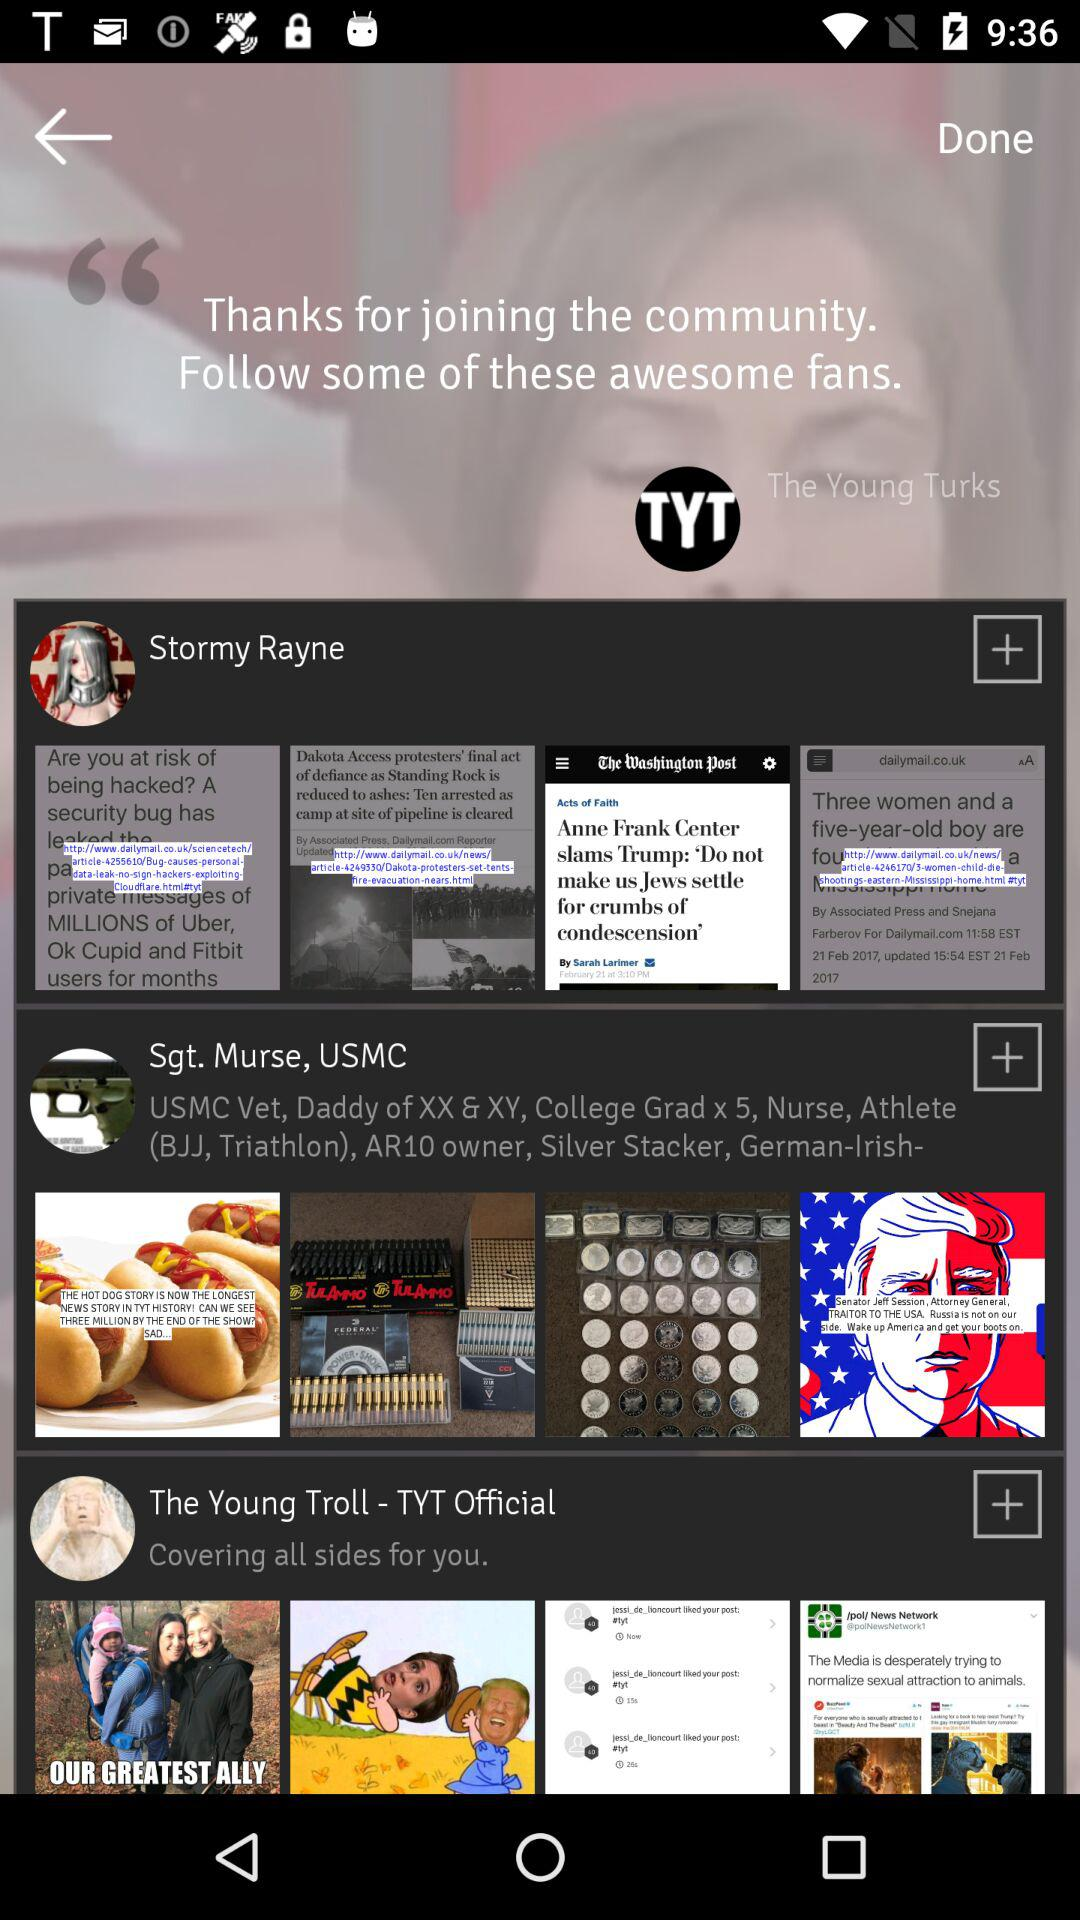What is the full form of "TYT"? The full form is "The Young Turks". 